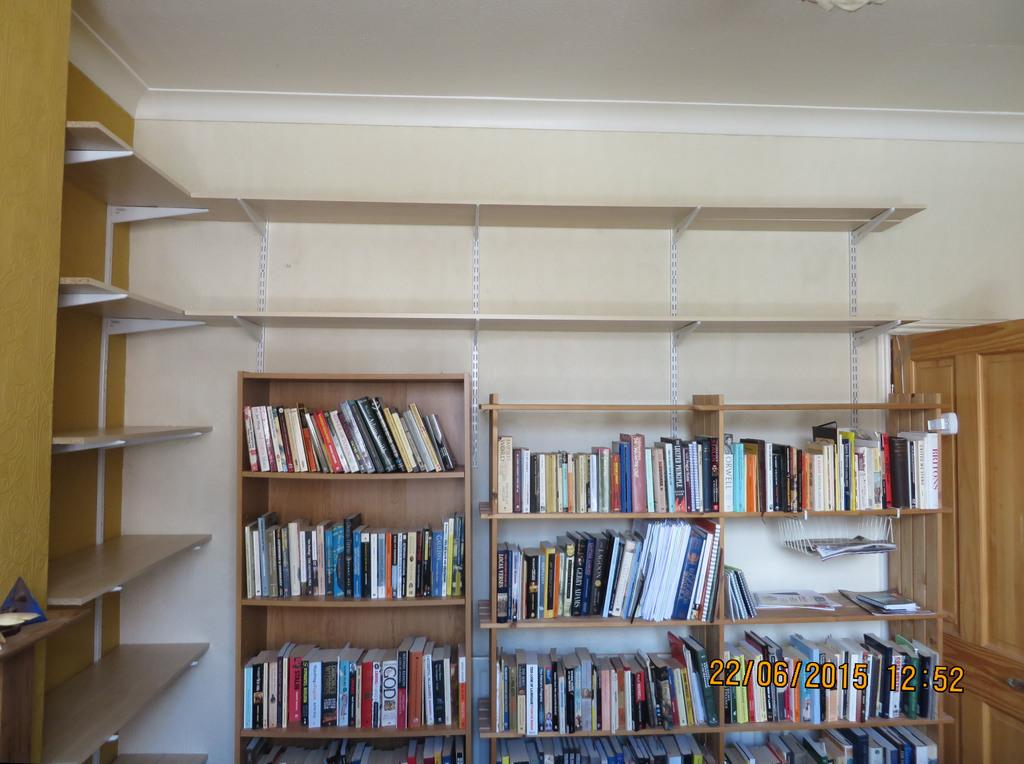What can be seen on the racks in the image? There are books on the racks in the image. What is visible behind the racks in the image? There is a wall in the background of the image. What type of plate is being used to hold the books on the racks? There is no plate present in the image; the books are directly on the racks. 